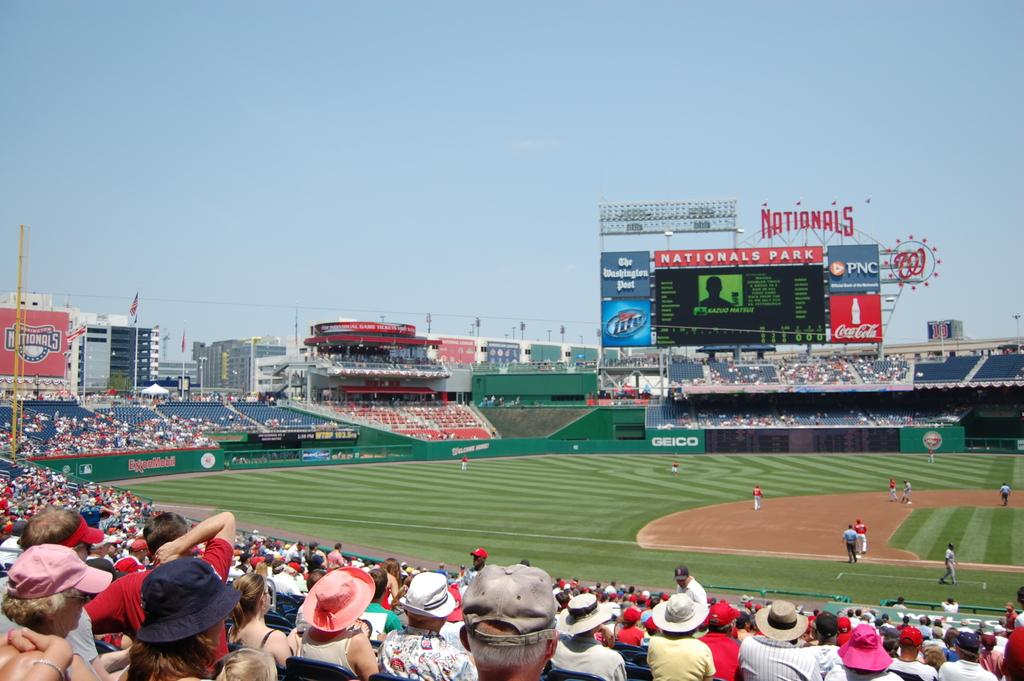<image>
Relay a brief, clear account of the picture shown. the team name Nationals sits on the top of a socreboard 